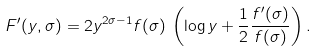<formula> <loc_0><loc_0><loc_500><loc_500>F ^ { \prime } ( y , \sigma ) = 2 y ^ { 2 \sigma - 1 } f ( \sigma ) \, \left ( \log y + \frac { 1 } { 2 } \frac { f ^ { \prime } ( \sigma ) } { f ( \sigma ) } \right ) .</formula> 